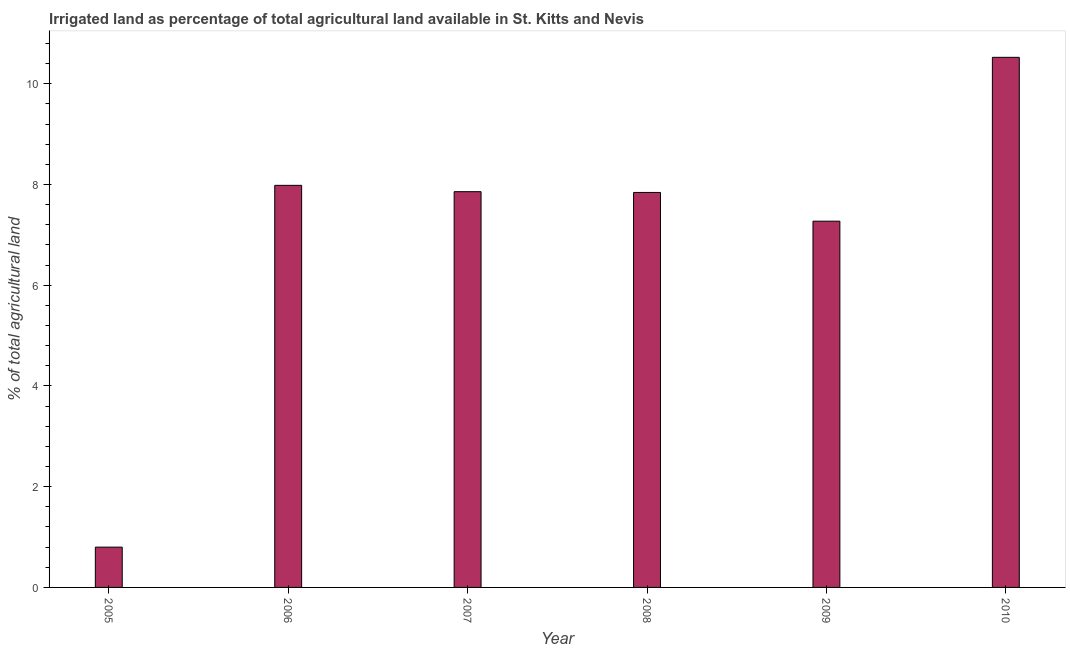Does the graph contain grids?
Offer a terse response. No. What is the title of the graph?
Provide a short and direct response. Irrigated land as percentage of total agricultural land available in St. Kitts and Nevis. What is the label or title of the X-axis?
Give a very brief answer. Year. What is the label or title of the Y-axis?
Give a very brief answer. % of total agricultural land. What is the percentage of agricultural irrigated land in 2010?
Provide a short and direct response. 10.53. Across all years, what is the maximum percentage of agricultural irrigated land?
Your response must be concise. 10.53. In which year was the percentage of agricultural irrigated land maximum?
Ensure brevity in your answer.  2010. In which year was the percentage of agricultural irrigated land minimum?
Give a very brief answer. 2005. What is the sum of the percentage of agricultural irrigated land?
Offer a terse response. 42.28. What is the difference between the percentage of agricultural irrigated land in 2005 and 2010?
Provide a succinct answer. -9.73. What is the average percentage of agricultural irrigated land per year?
Offer a very short reply. 7.05. What is the median percentage of agricultural irrigated land?
Give a very brief answer. 7.85. In how many years, is the percentage of agricultural irrigated land greater than 9.6 %?
Provide a short and direct response. 1. What is the ratio of the percentage of agricultural irrigated land in 2009 to that in 2010?
Make the answer very short. 0.69. Is the difference between the percentage of agricultural irrigated land in 2007 and 2008 greater than the difference between any two years?
Offer a very short reply. No. What is the difference between the highest and the second highest percentage of agricultural irrigated land?
Ensure brevity in your answer.  2.54. What is the difference between the highest and the lowest percentage of agricultural irrigated land?
Make the answer very short. 9.73. How many bars are there?
Keep it short and to the point. 6. What is the difference between two consecutive major ticks on the Y-axis?
Your answer should be very brief. 2. What is the % of total agricultural land of 2005?
Offer a very short reply. 0.8. What is the % of total agricultural land in 2006?
Provide a short and direct response. 7.98. What is the % of total agricultural land of 2007?
Your answer should be very brief. 7.86. What is the % of total agricultural land in 2008?
Your response must be concise. 7.84. What is the % of total agricultural land of 2009?
Provide a succinct answer. 7.27. What is the % of total agricultural land of 2010?
Give a very brief answer. 10.53. What is the difference between the % of total agricultural land in 2005 and 2006?
Give a very brief answer. -7.18. What is the difference between the % of total agricultural land in 2005 and 2007?
Your answer should be compact. -7.06. What is the difference between the % of total agricultural land in 2005 and 2008?
Give a very brief answer. -7.04. What is the difference between the % of total agricultural land in 2005 and 2009?
Your answer should be compact. -6.47. What is the difference between the % of total agricultural land in 2005 and 2010?
Make the answer very short. -9.73. What is the difference between the % of total agricultural land in 2006 and 2007?
Provide a short and direct response. 0.13. What is the difference between the % of total agricultural land in 2006 and 2008?
Keep it short and to the point. 0.14. What is the difference between the % of total agricultural land in 2006 and 2009?
Keep it short and to the point. 0.71. What is the difference between the % of total agricultural land in 2006 and 2010?
Give a very brief answer. -2.54. What is the difference between the % of total agricultural land in 2007 and 2008?
Ensure brevity in your answer.  0.02. What is the difference between the % of total agricultural land in 2007 and 2009?
Offer a terse response. 0.59. What is the difference between the % of total agricultural land in 2007 and 2010?
Your response must be concise. -2.67. What is the difference between the % of total agricultural land in 2008 and 2009?
Ensure brevity in your answer.  0.57. What is the difference between the % of total agricultural land in 2008 and 2010?
Ensure brevity in your answer.  -2.68. What is the difference between the % of total agricultural land in 2009 and 2010?
Provide a short and direct response. -3.25. What is the ratio of the % of total agricultural land in 2005 to that in 2006?
Offer a terse response. 0.1. What is the ratio of the % of total agricultural land in 2005 to that in 2007?
Provide a succinct answer. 0.1. What is the ratio of the % of total agricultural land in 2005 to that in 2008?
Provide a short and direct response. 0.1. What is the ratio of the % of total agricultural land in 2005 to that in 2009?
Your answer should be compact. 0.11. What is the ratio of the % of total agricultural land in 2005 to that in 2010?
Provide a short and direct response. 0.08. What is the ratio of the % of total agricultural land in 2006 to that in 2008?
Offer a terse response. 1.02. What is the ratio of the % of total agricultural land in 2006 to that in 2009?
Offer a very short reply. 1.1. What is the ratio of the % of total agricultural land in 2006 to that in 2010?
Your answer should be compact. 0.76. What is the ratio of the % of total agricultural land in 2007 to that in 2008?
Give a very brief answer. 1. What is the ratio of the % of total agricultural land in 2007 to that in 2009?
Ensure brevity in your answer.  1.08. What is the ratio of the % of total agricultural land in 2007 to that in 2010?
Give a very brief answer. 0.75. What is the ratio of the % of total agricultural land in 2008 to that in 2009?
Give a very brief answer. 1.08. What is the ratio of the % of total agricultural land in 2008 to that in 2010?
Provide a short and direct response. 0.74. What is the ratio of the % of total agricultural land in 2009 to that in 2010?
Provide a succinct answer. 0.69. 